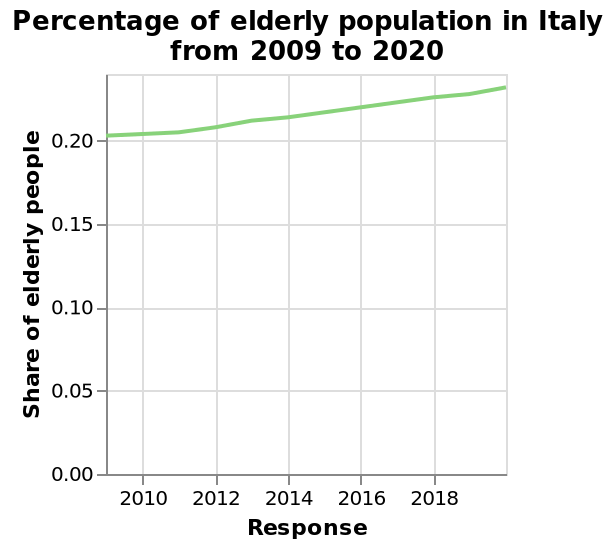<image>
Is the growth rate of the elderly population consistent? No, the growth rate of the elderly population is increasing exponentially. What is the range of the x-axis on the line plot? The range of the x-axis on the line plot is from 2010 to 2018. 